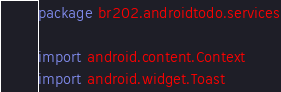Convert code to text. <code><loc_0><loc_0><loc_500><loc_500><_Kotlin_>package br202.androidtodo.services

import android.content.Context
import android.widget.Toast</code> 